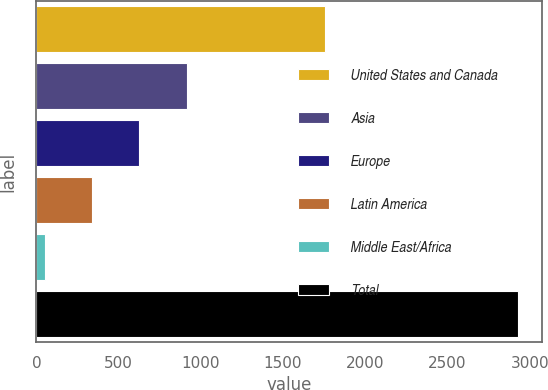Convert chart. <chart><loc_0><loc_0><loc_500><loc_500><bar_chart><fcel>United States and Canada<fcel>Asia<fcel>Europe<fcel>Latin America<fcel>Middle East/Africa<fcel>Total<nl><fcel>1756<fcel>913.7<fcel>625.8<fcel>337.9<fcel>50<fcel>2929<nl></chart> 